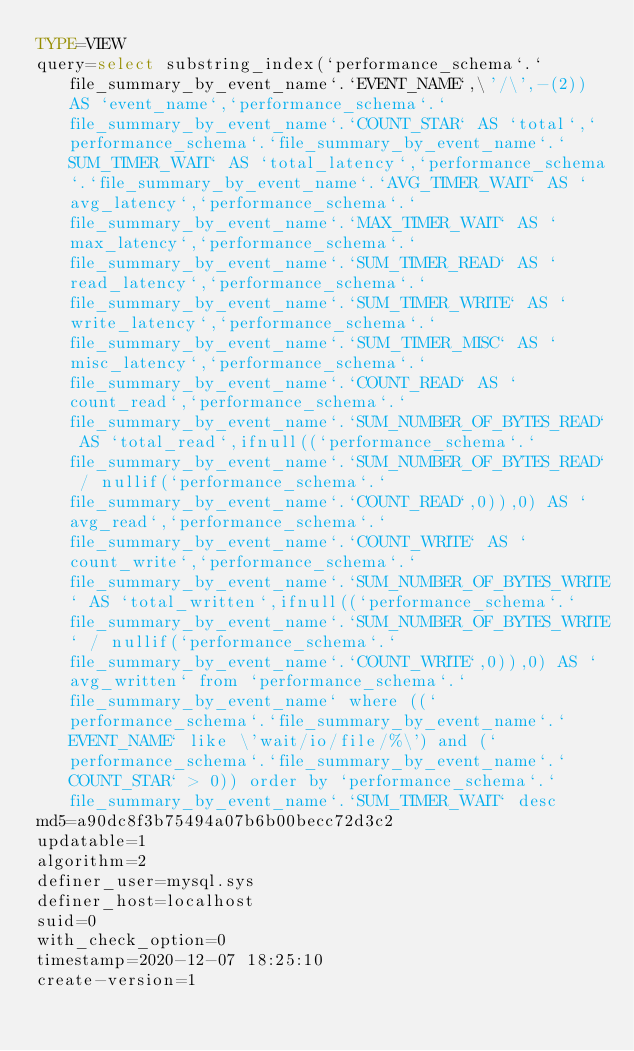Convert code to text. <code><loc_0><loc_0><loc_500><loc_500><_VisualBasic_>TYPE=VIEW
query=select substring_index(`performance_schema`.`file_summary_by_event_name`.`EVENT_NAME`,\'/\',-(2)) AS `event_name`,`performance_schema`.`file_summary_by_event_name`.`COUNT_STAR` AS `total`,`performance_schema`.`file_summary_by_event_name`.`SUM_TIMER_WAIT` AS `total_latency`,`performance_schema`.`file_summary_by_event_name`.`AVG_TIMER_WAIT` AS `avg_latency`,`performance_schema`.`file_summary_by_event_name`.`MAX_TIMER_WAIT` AS `max_latency`,`performance_schema`.`file_summary_by_event_name`.`SUM_TIMER_READ` AS `read_latency`,`performance_schema`.`file_summary_by_event_name`.`SUM_TIMER_WRITE` AS `write_latency`,`performance_schema`.`file_summary_by_event_name`.`SUM_TIMER_MISC` AS `misc_latency`,`performance_schema`.`file_summary_by_event_name`.`COUNT_READ` AS `count_read`,`performance_schema`.`file_summary_by_event_name`.`SUM_NUMBER_OF_BYTES_READ` AS `total_read`,ifnull((`performance_schema`.`file_summary_by_event_name`.`SUM_NUMBER_OF_BYTES_READ` / nullif(`performance_schema`.`file_summary_by_event_name`.`COUNT_READ`,0)),0) AS `avg_read`,`performance_schema`.`file_summary_by_event_name`.`COUNT_WRITE` AS `count_write`,`performance_schema`.`file_summary_by_event_name`.`SUM_NUMBER_OF_BYTES_WRITE` AS `total_written`,ifnull((`performance_schema`.`file_summary_by_event_name`.`SUM_NUMBER_OF_BYTES_WRITE` / nullif(`performance_schema`.`file_summary_by_event_name`.`COUNT_WRITE`,0)),0) AS `avg_written` from `performance_schema`.`file_summary_by_event_name` where ((`performance_schema`.`file_summary_by_event_name`.`EVENT_NAME` like \'wait/io/file/%\') and (`performance_schema`.`file_summary_by_event_name`.`COUNT_STAR` > 0)) order by `performance_schema`.`file_summary_by_event_name`.`SUM_TIMER_WAIT` desc
md5=a90dc8f3b75494a07b6b00becc72d3c2
updatable=1
algorithm=2
definer_user=mysql.sys
definer_host=localhost
suid=0
with_check_option=0
timestamp=2020-12-07 18:25:10
create-version=1</code> 